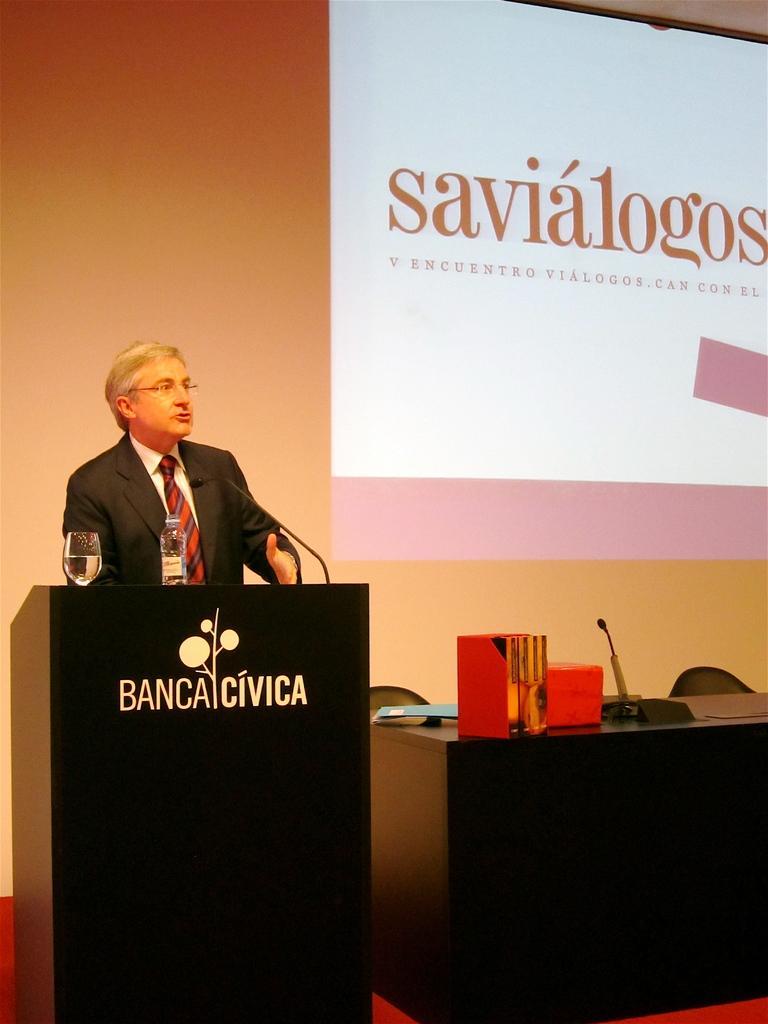In one or two sentences, can you explain what this image depicts? In this image we can see a person is standing near a podium and talking. There is a bottle and a drink glass on the table. There are some objects placed on the table. There is a projector screen at the top right most of the image. 